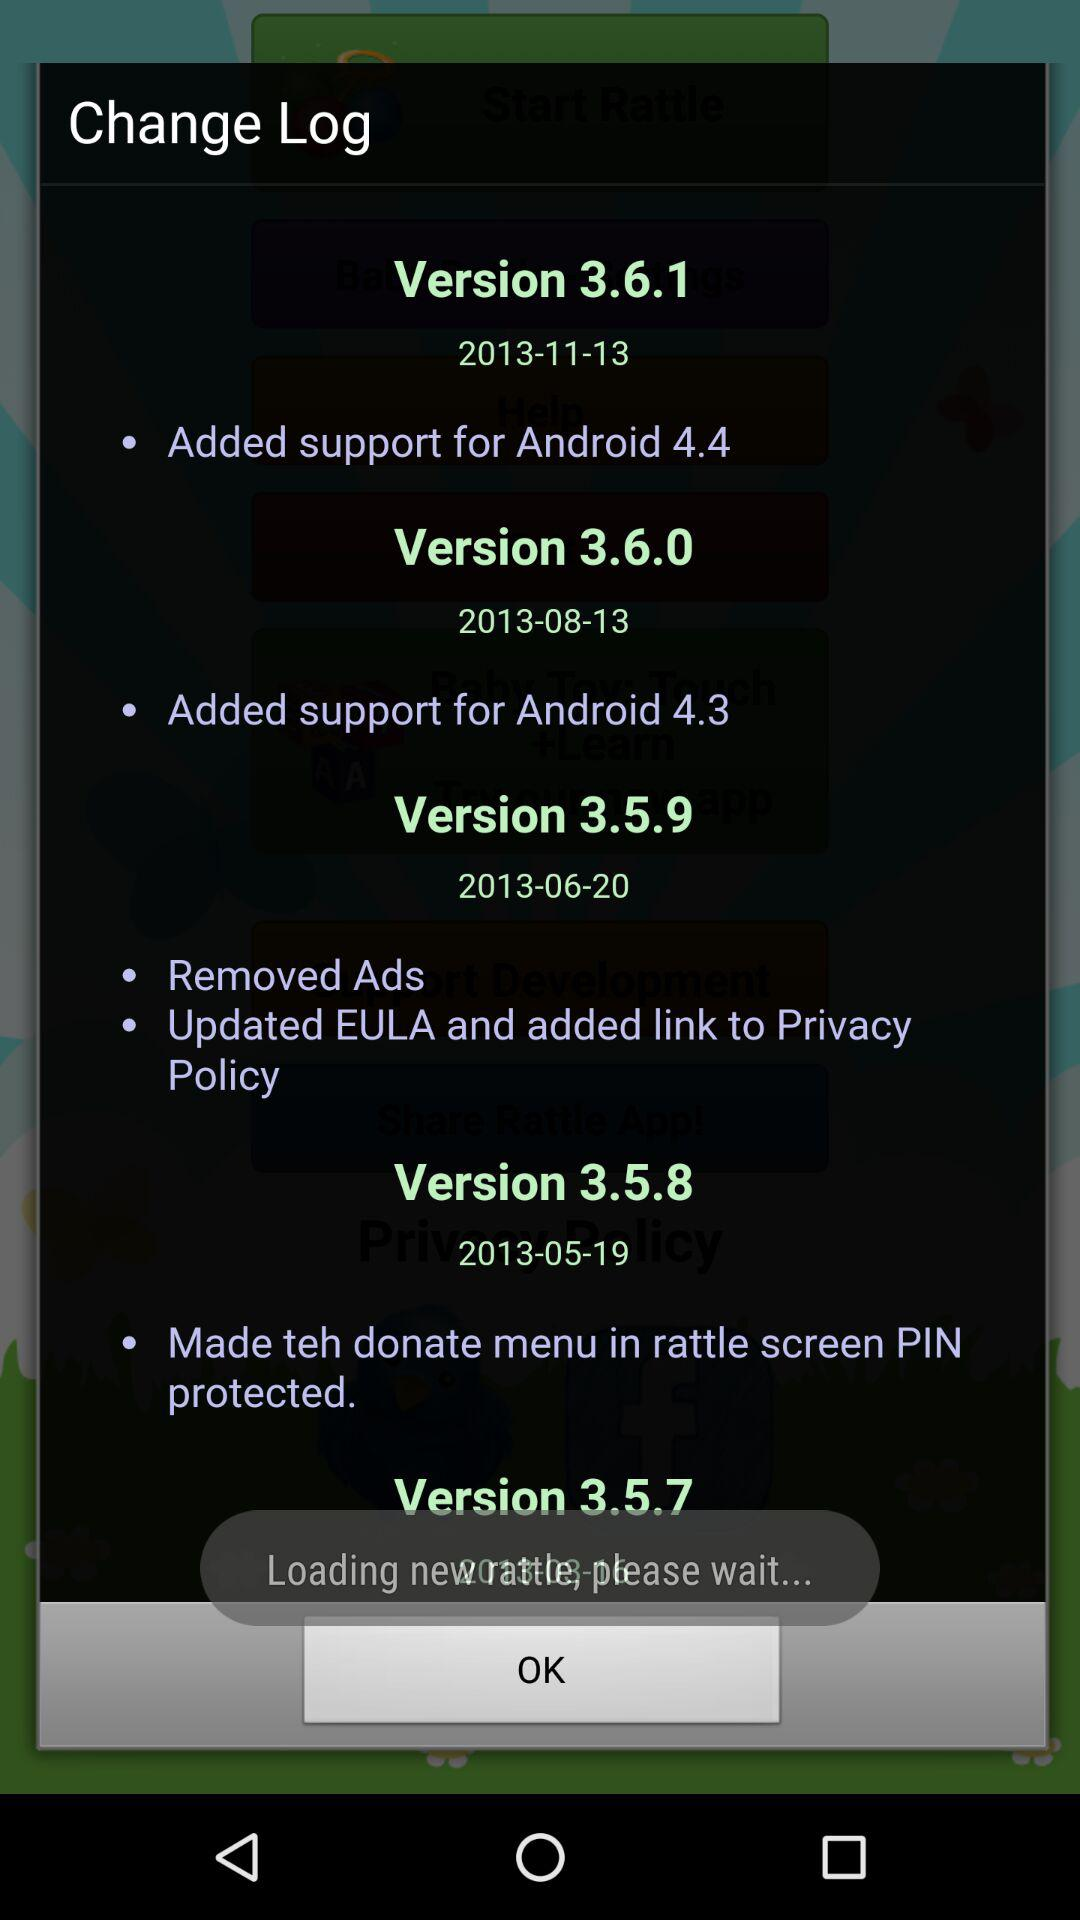What version was released on 2013-11-13? The version is 3.6.1. 